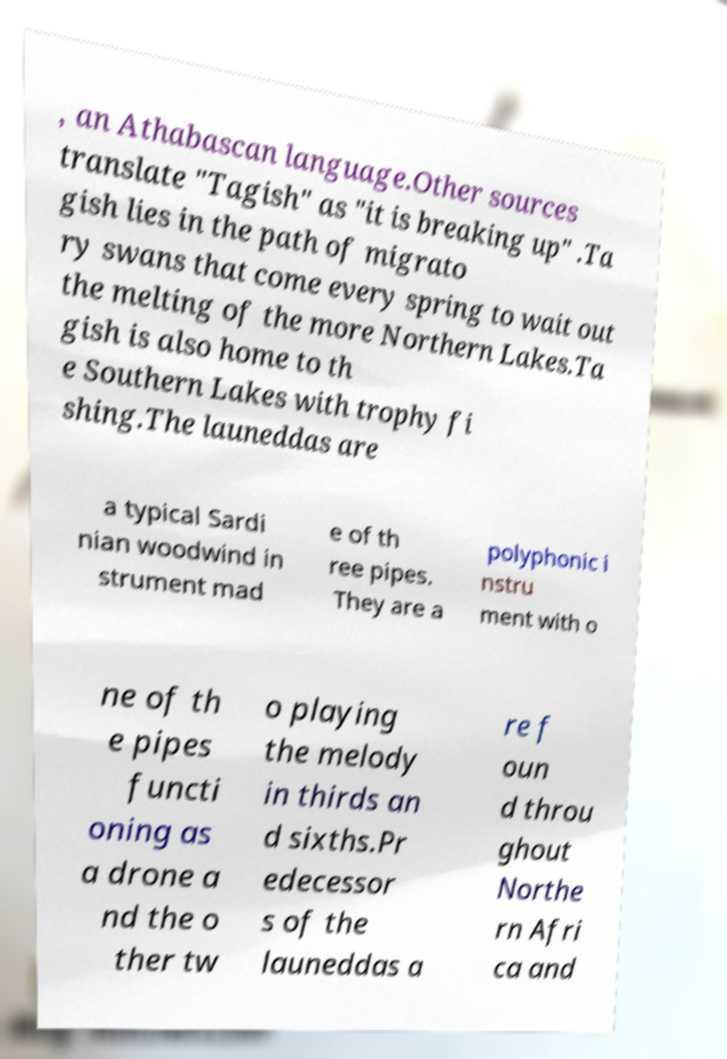What messages or text are displayed in this image? I need them in a readable, typed format. , an Athabascan language.Other sources translate "Tagish" as "it is breaking up" .Ta gish lies in the path of migrato ry swans that come every spring to wait out the melting of the more Northern Lakes.Ta gish is also home to th e Southern Lakes with trophy fi shing.The launeddas are a typical Sardi nian woodwind in strument mad e of th ree pipes. They are a polyphonic i nstru ment with o ne of th e pipes functi oning as a drone a nd the o ther tw o playing the melody in thirds an d sixths.Pr edecessor s of the launeddas a re f oun d throu ghout Northe rn Afri ca and 